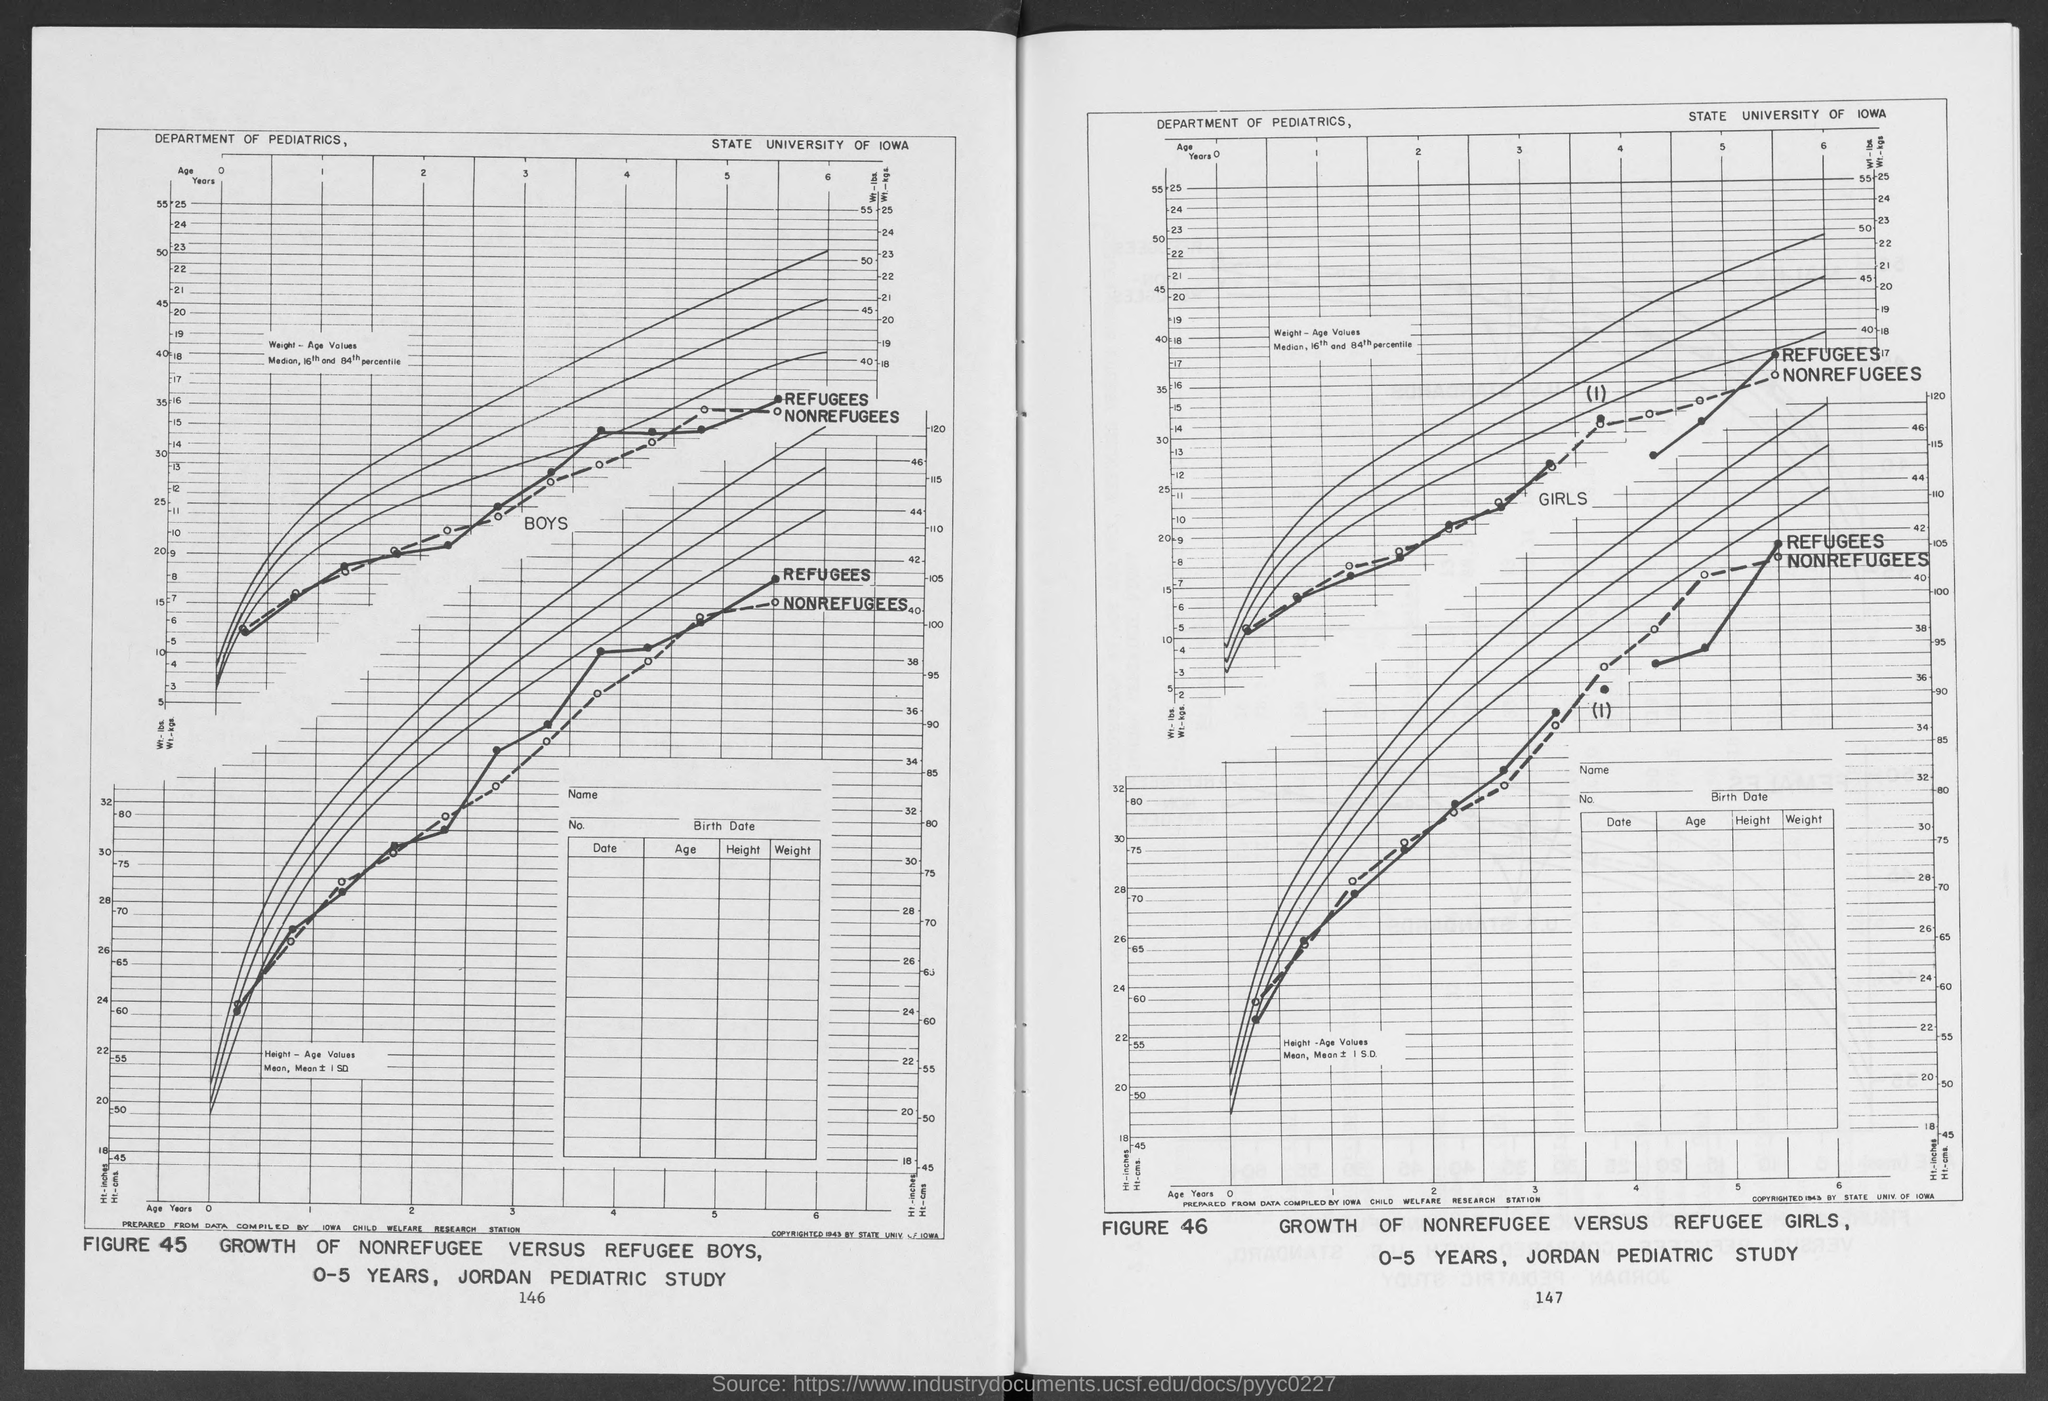Which department is the graph by?
Your response must be concise. Department of pediatrics. What is the university name?
Offer a terse response. State university of IOWA. What is the title of Figure 45?
Provide a succinct answer. Growth of nonrefugee versus refugee boys. What is the age group of the boys in the study?
Offer a terse response. 0-5 Years. 